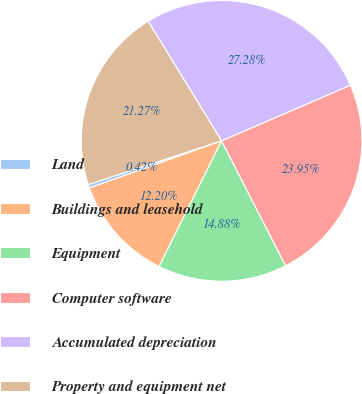Convert chart to OTSL. <chart><loc_0><loc_0><loc_500><loc_500><pie_chart><fcel>Land<fcel>Buildings and leasehold<fcel>Equipment<fcel>Computer software<fcel>Accumulated depreciation<fcel>Property and equipment net<nl><fcel>0.42%<fcel>12.2%<fcel>14.88%<fcel>23.95%<fcel>27.28%<fcel>21.27%<nl></chart> 